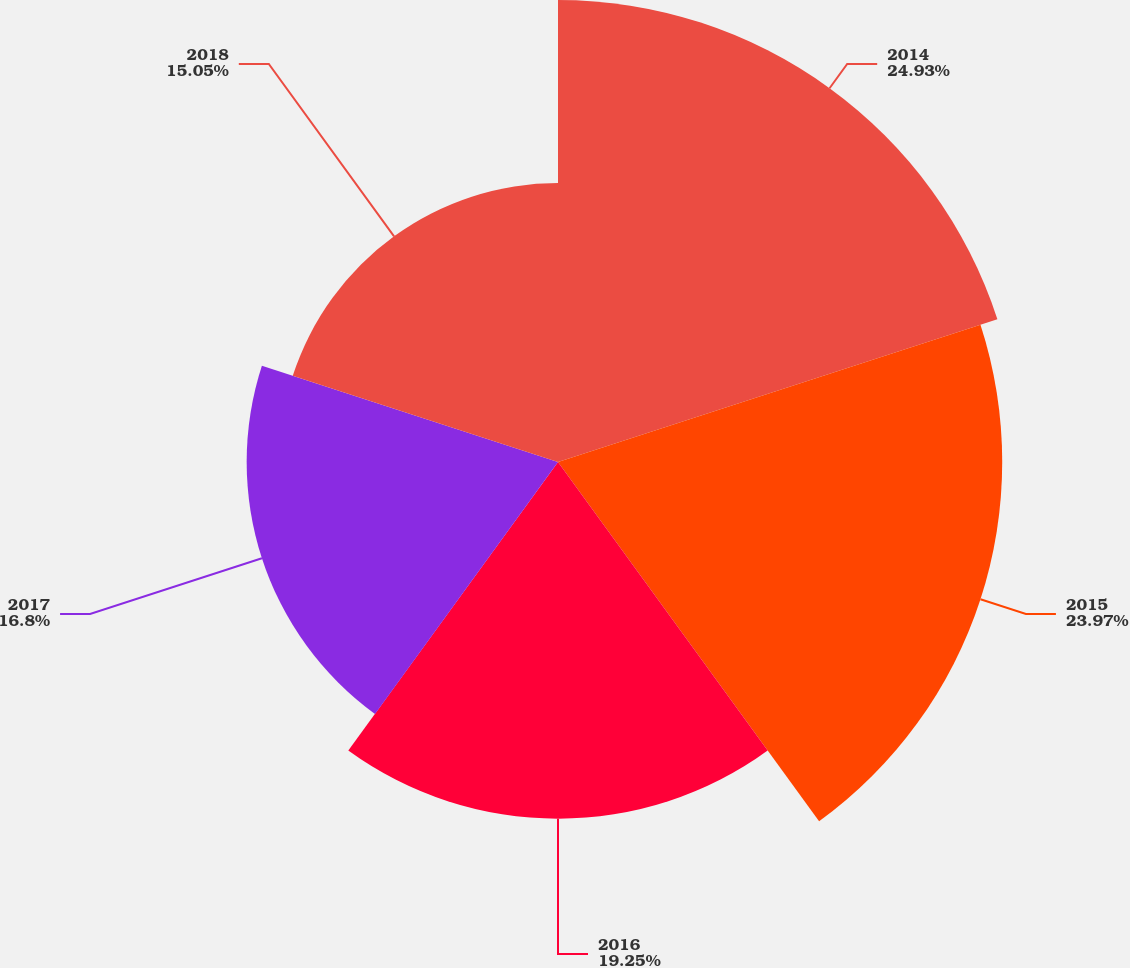Convert chart to OTSL. <chart><loc_0><loc_0><loc_500><loc_500><pie_chart><fcel>2014<fcel>2015<fcel>2016<fcel>2017<fcel>2018<nl><fcel>24.93%<fcel>23.97%<fcel>19.25%<fcel>16.8%<fcel>15.05%<nl></chart> 